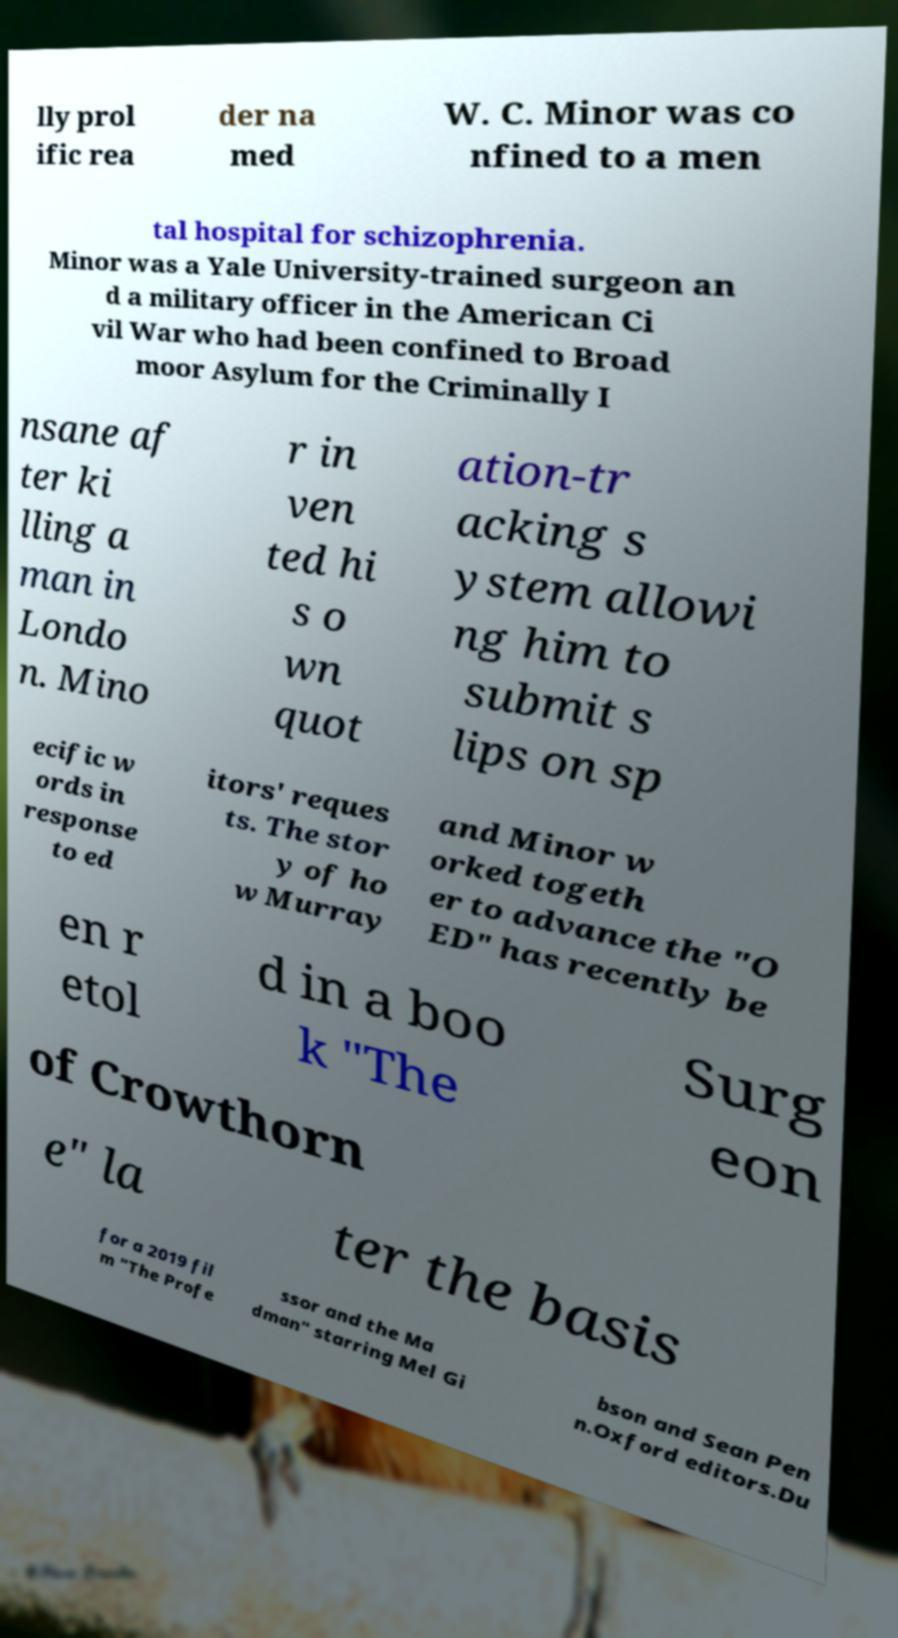Can you accurately transcribe the text from the provided image for me? lly prol ific rea der na med W. C. Minor was co nfined to a men tal hospital for schizophrenia. Minor was a Yale University-trained surgeon an d a military officer in the American Ci vil War who had been confined to Broad moor Asylum for the Criminally I nsane af ter ki lling a man in Londo n. Mino r in ven ted hi s o wn quot ation-tr acking s ystem allowi ng him to submit s lips on sp ecific w ords in response to ed itors' reques ts. The stor y of ho w Murray and Minor w orked togeth er to advance the "O ED" has recently be en r etol d in a boo k "The Surg eon of Crowthorn e" la ter the basis for a 2019 fil m "The Profe ssor and the Ma dman" starring Mel Gi bson and Sean Pen n.Oxford editors.Du 